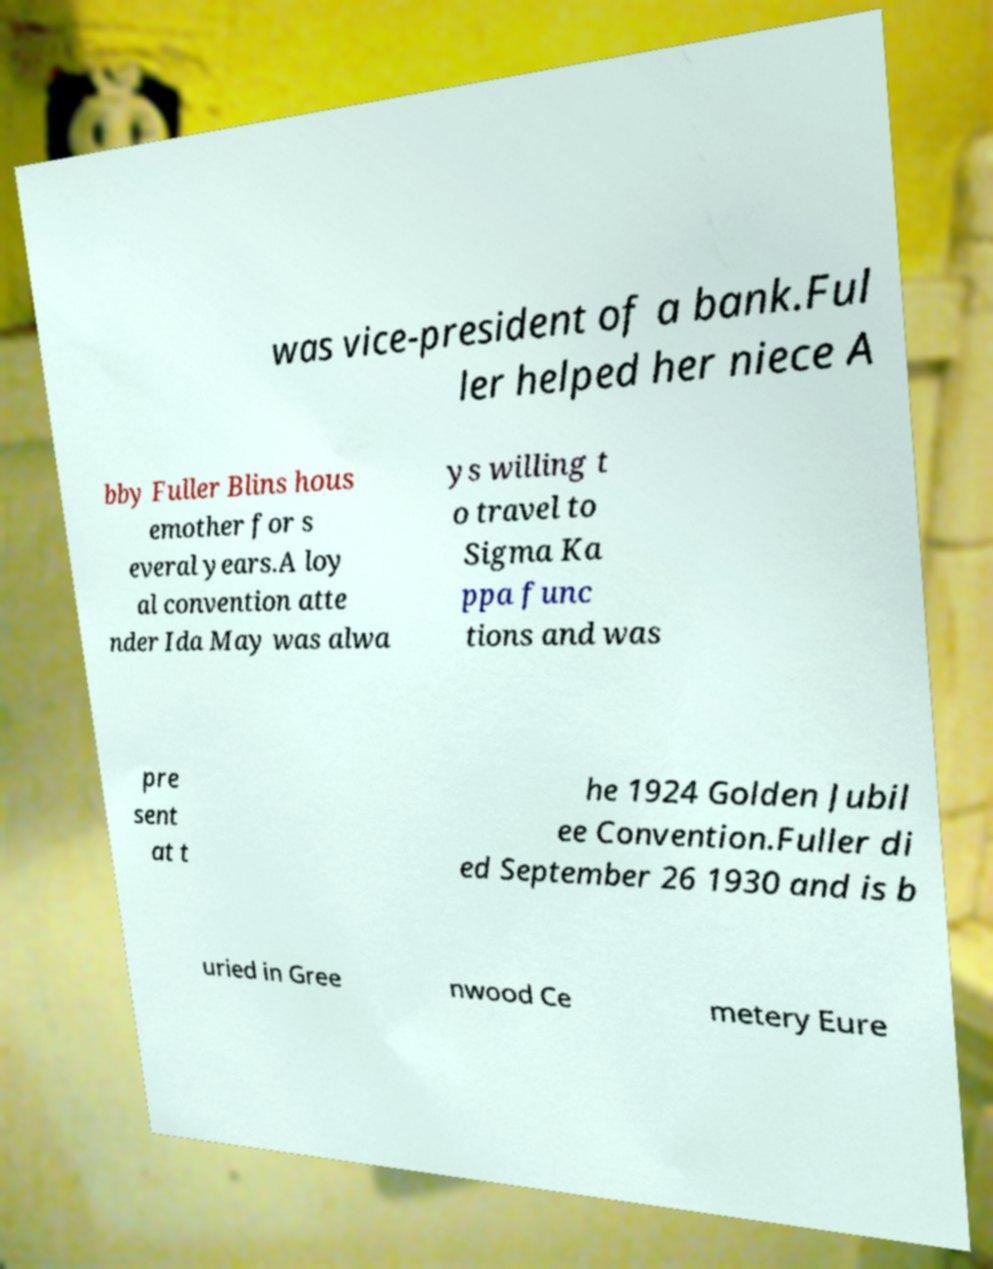Can you read and provide the text displayed in the image?This photo seems to have some interesting text. Can you extract and type it out for me? was vice-president of a bank.Ful ler helped her niece A bby Fuller Blins hous emother for s everal years.A loy al convention atte nder Ida May was alwa ys willing t o travel to Sigma Ka ppa func tions and was pre sent at t he 1924 Golden Jubil ee Convention.Fuller di ed September 26 1930 and is b uried in Gree nwood Ce metery Eure 